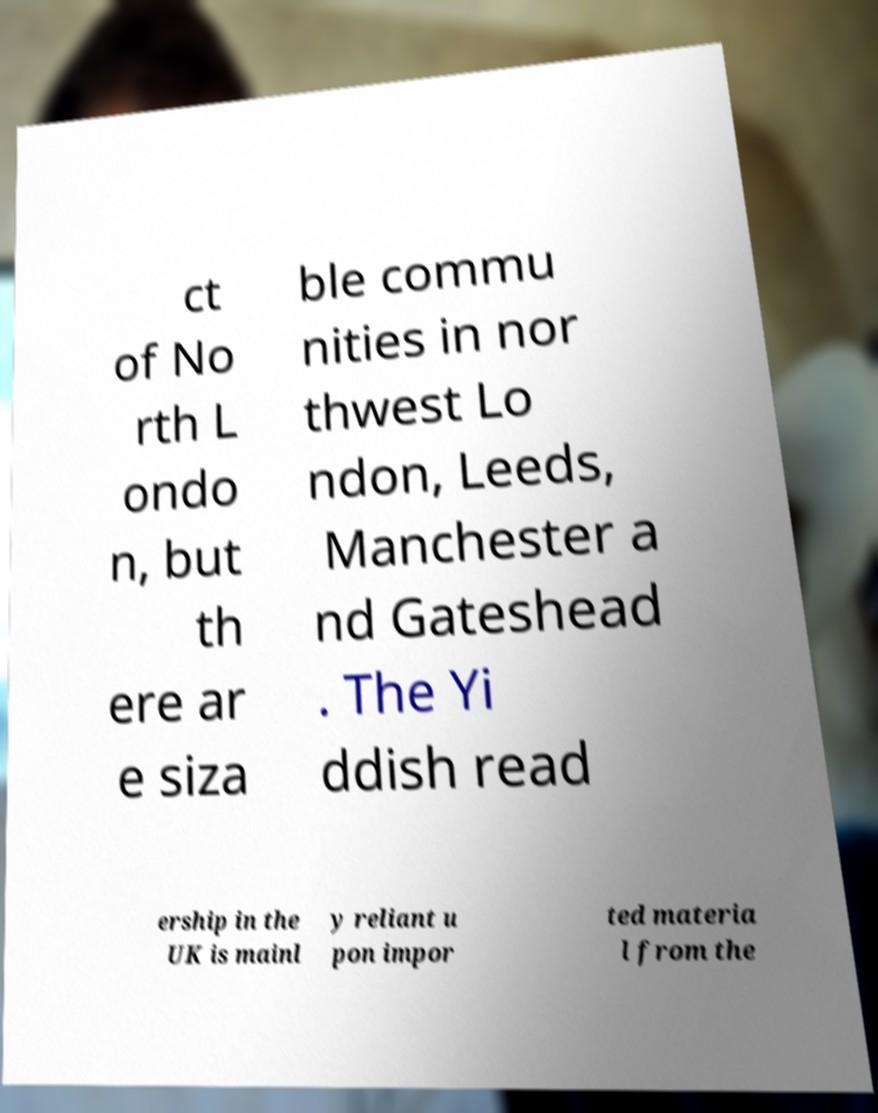For documentation purposes, I need the text within this image transcribed. Could you provide that? ct of No rth L ondo n, but th ere ar e siza ble commu nities in nor thwest Lo ndon, Leeds, Manchester a nd Gateshead . The Yi ddish read ership in the UK is mainl y reliant u pon impor ted materia l from the 